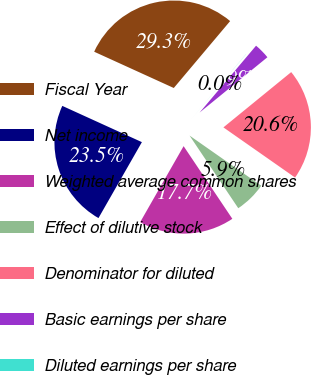Convert chart. <chart><loc_0><loc_0><loc_500><loc_500><pie_chart><fcel>Fiscal Year<fcel>Net income<fcel>Weighted average common shares<fcel>Effect of dilutive stock<fcel>Denominator for diluted<fcel>Basic earnings per share<fcel>Diluted earnings per share<nl><fcel>29.34%<fcel>23.54%<fcel>17.67%<fcel>5.88%<fcel>20.61%<fcel>2.95%<fcel>0.02%<nl></chart> 